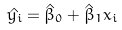Convert formula to latex. <formula><loc_0><loc_0><loc_500><loc_500>\hat { y _ { i } } = \hat { \beta } _ { 0 } + \hat { \beta } _ { 1 } x _ { i }</formula> 